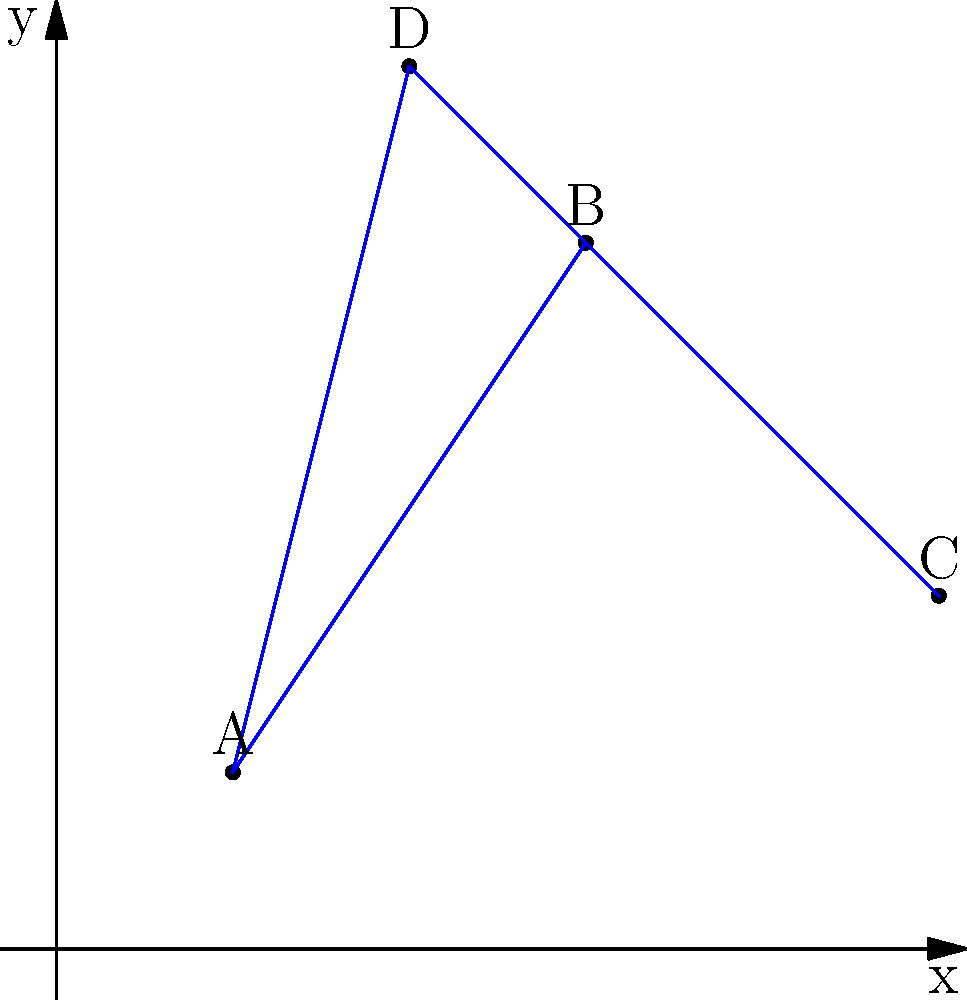As a travel agent coordinating culinary tours, you need to optimize the route between four popular foodie destinations. The destinations are plotted on a coordinate plane as follows:

A (1,1): Local market
B (3,4): Michelin-starred restaurant
C (5,2): Winery
D (2,5): Cooking school

What is the total distance traveled if the tour visits these destinations in the order A → B → C → D → A? To solve this problem, we need to calculate the distances between consecutive points and sum them up. We can use the distance formula between two points $(x_1, y_1)$ and $(x_2, y_2)$:

$d = \sqrt{(x_2 - x_1)^2 + (y_2 - y_1)^2}$

Let's calculate each segment:

1. A to B: $d_{AB} = \sqrt{(3-1)^2 + (4-1)^2} = \sqrt{4 + 9} = \sqrt{13}$

2. B to C: $d_{BC} = \sqrt{(5-3)^2 + (2-4)^2} = \sqrt{4 + 4} = \sqrt{8} = 2\sqrt{2}$

3. C to D: $d_{CD} = \sqrt{(2-5)^2 + (5-2)^2} = \sqrt{9 + 9} = \sqrt{18} = 3\sqrt{2}$

4. D to A: $d_{DA} = \sqrt{(1-2)^2 + (1-5)^2} = \sqrt{1 + 16} = \sqrt{17}$

Now, we sum up all these distances:

$d_{total} = \sqrt{13} + 2\sqrt{2} + 3\sqrt{2} + \sqrt{17}$

$d_{total} = \sqrt{13} + 5\sqrt{2} + \sqrt{17}$

This is the exact expression for the total distance traveled.
Answer: $\sqrt{13} + 5\sqrt{2} + \sqrt{17}$ 